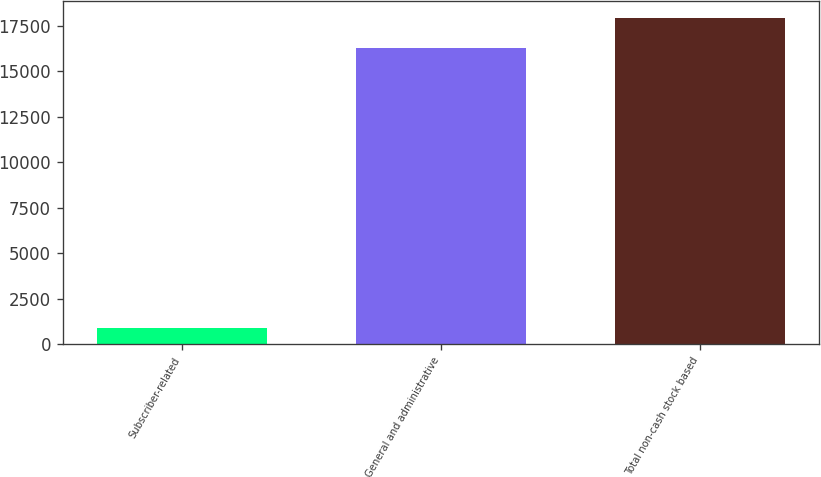<chart> <loc_0><loc_0><loc_500><loc_500><bar_chart><fcel>Subscriber-related<fcel>General and administrative<fcel>Total non-cash stock based<nl><fcel>879<fcel>16254<fcel>17930.6<nl></chart> 